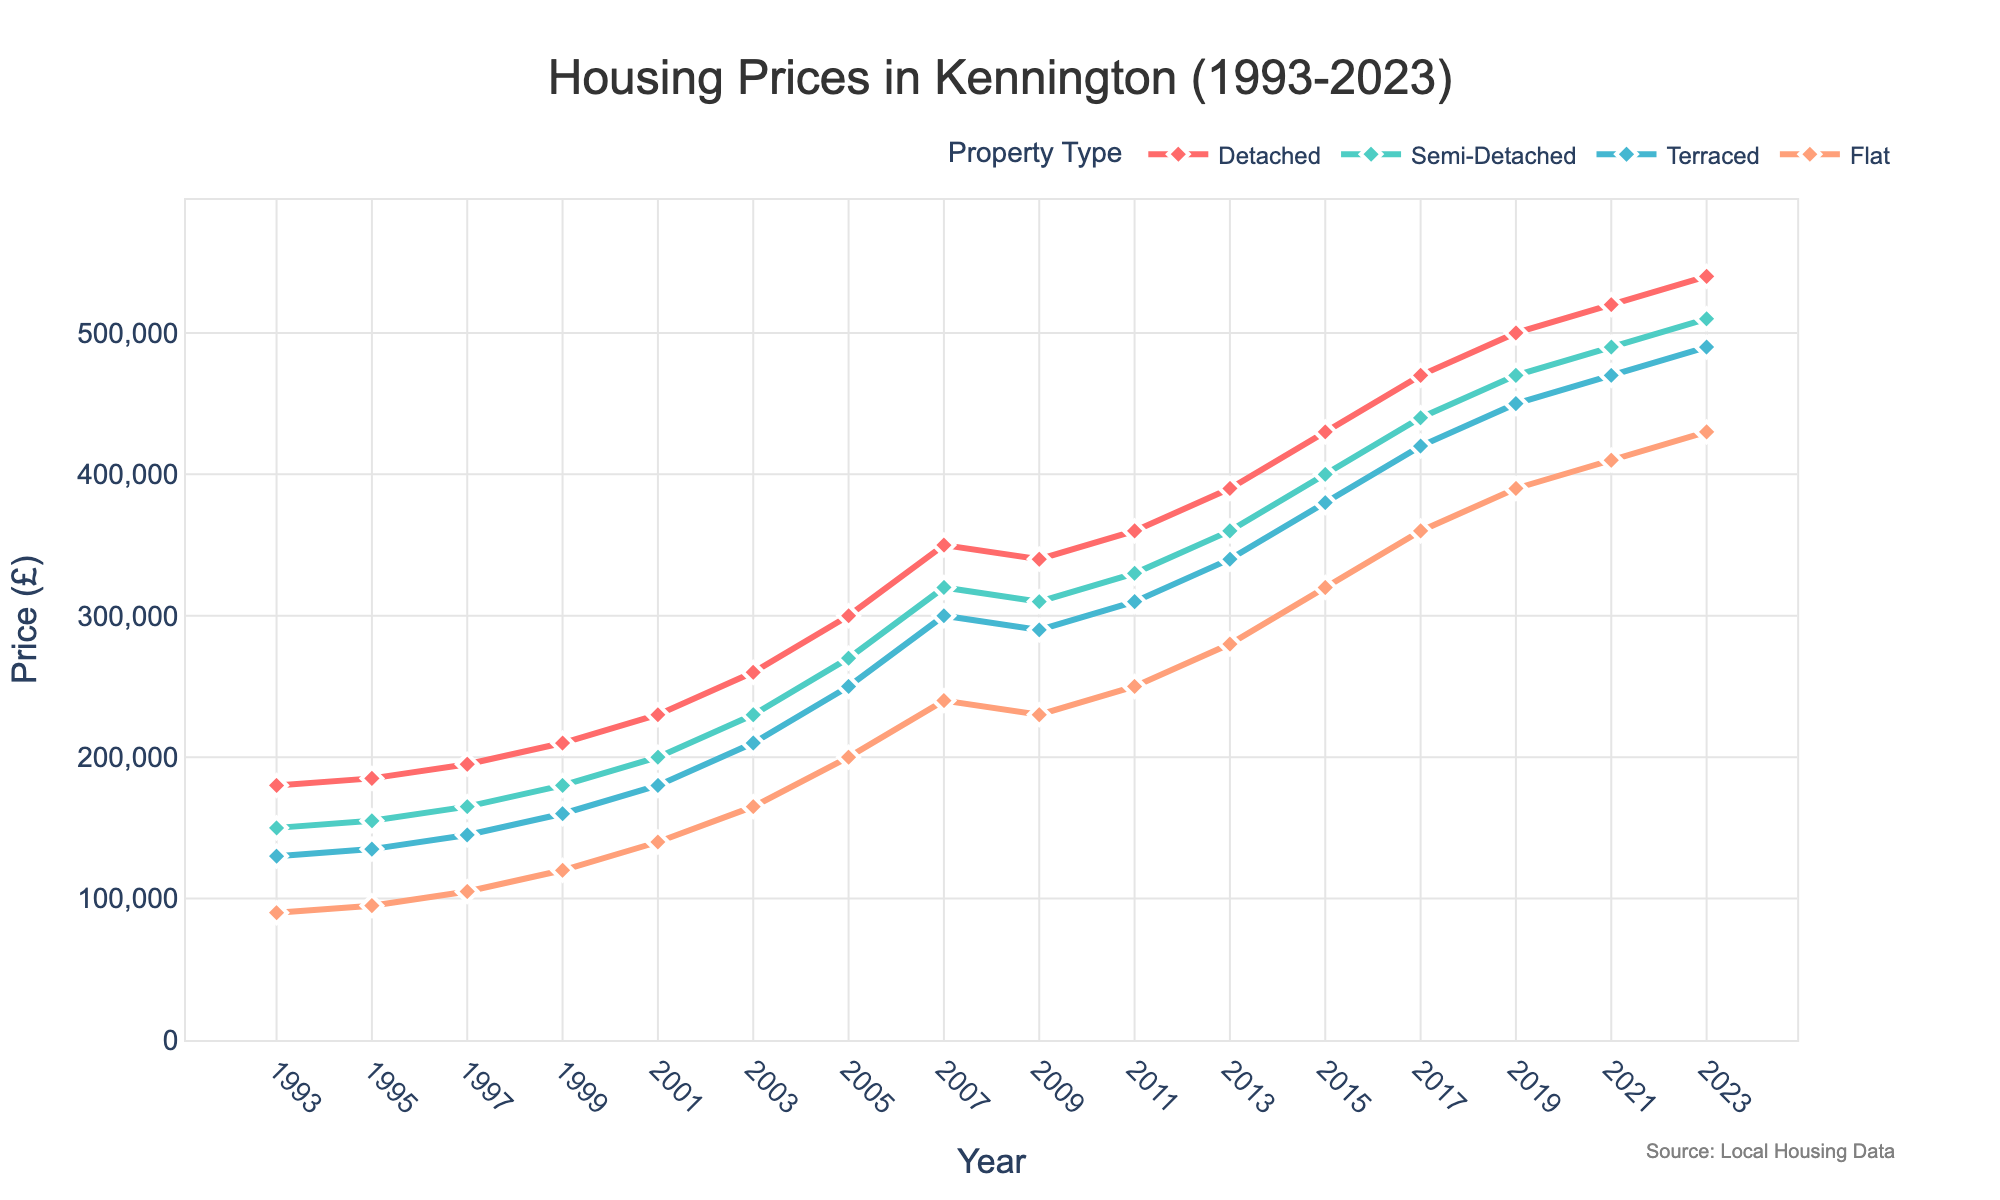What is the difference in price between Detached and Flats in 2023? To find the difference in price between Detached and Flats in 2023, subtract the price of Flats from the price of Detached for the year 2023: 540,000 - 430,000 = 110,000.
Answer: 110,000 Which property type had the highest price in 2005? By looking at the plot for the year 2005, Detached properties have the highest price among the four property types, with a value of 300,000.
Answer: Detached How has the price of Semi-Detached houses changed from 1993 to 2023? To calculate the price change of Semi-Detached houses from 1993 to 2023, subtract the price in 1993 (150,000) from the price in 2023 (510,000): 510,000 - 150,000 = 360,000.
Answer: Increased by 360,000 Which property type showed the smallest increase in price from 2001 to 2003? By checking the plot, the price increase for each property type from 2001 to 2003 is: Detached (30,000), Semi-Detached (30,000), Terraced (30,000), Flats (25,000). Flats show the smallest increase.
Answer: Flats By how much did the Terraced property prices rise during the period from 2007 to 2011? To determine the rise, subtract the price in 2007 (300,000) from the price in 2011 (310,000): 310,000 - 300,000 = 10,000.
Answer: 10,000 When did the prices of Flats first exceed 300,000? By observing the plot, Flats prices first exceed 300,000 in the year 2015.
Answer: 2015 In which year did Detached house prices reach 500,000? By observing the plot, Detached house prices reach 500,000 in the year 2019.
Answer: 2019 